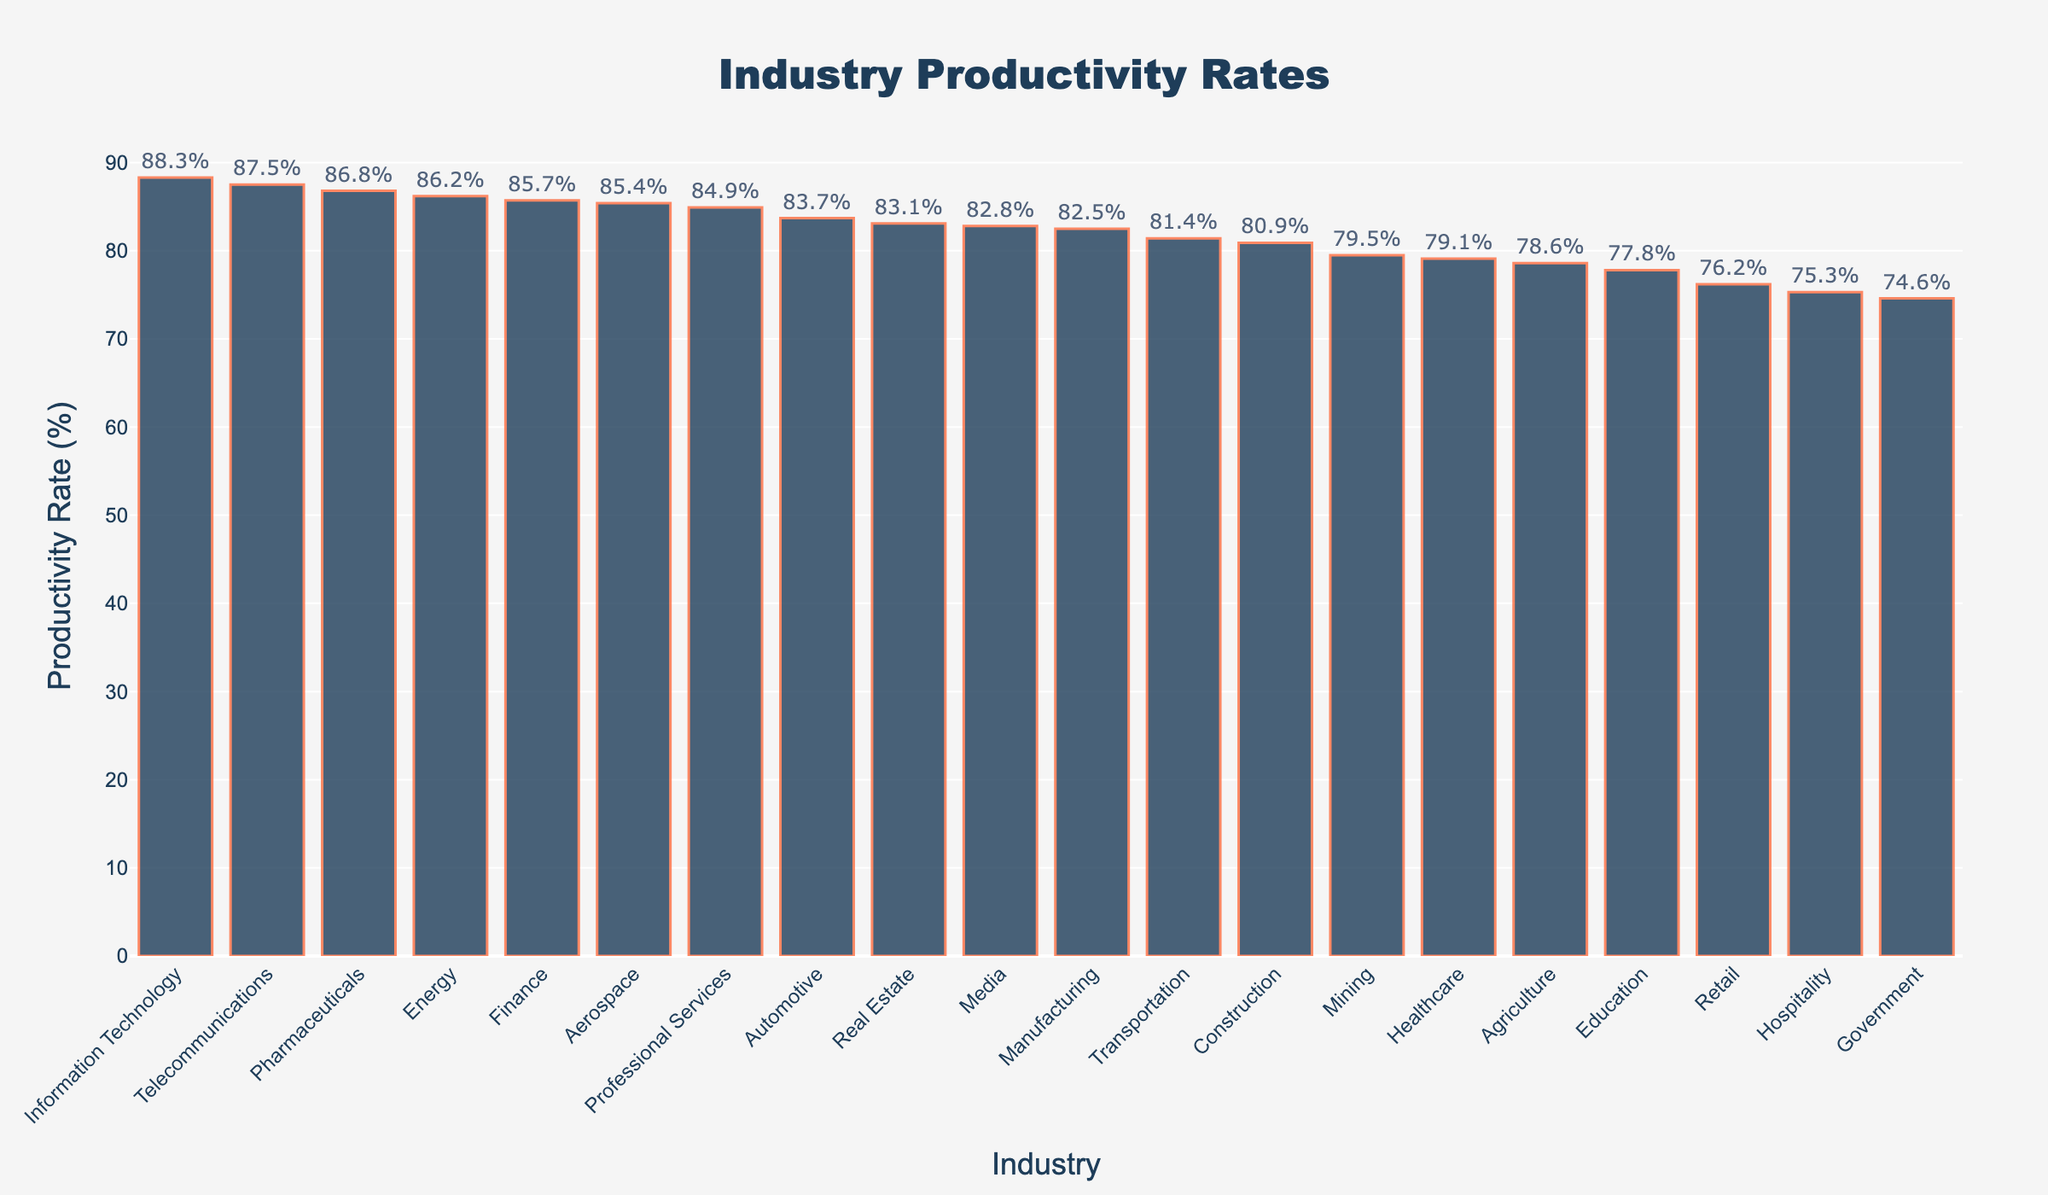Which industry has the highest productivity rate? The highest bar represents the industry with the highest productivity rate.
Answer: Information Technology Which industry has the lowest productivity rate? The lowest bar represents the industry with the lowest productivity rate.
Answer: Government What is the difference in productivity rates between Manufacturing and Retail? Look at and subtract the productivity rates of Manufacturing (82.5%) and Retail (76.2%). The difference is 82.5% - 76.2%.
Answer: 6.3% How many industries have a productivity rate above 85%? Count the bars with productivity rates above the 85% mark on the y-axis.
Answer: 6 Which industries have a productivity rate between 80% and 85% inclusive? Identify bars within the 80%-85% range on the y-axis.
Answer: Real Estate, Professional Services, Automotive, Transportation, Construction Is the productivity rate of Finance higher than that of Education? Compare the heights of the bars for Finance and Education or refer to their values.
Answer: Yes What is the average productivity rate of the top 5 industries? Sum the productivity rates of the top 5 industries (88.3%, 87.5%, 86.8%, 86.2%, 85.7%) and divide by 5.
Answer: 86.9% Which two industries have the closest productivity rates to each other? Find two bars whose heights are closest to each other or their values are closest.
Answer: Media and Manufacturing What is the productivity rate range (difference between the highest and lowest rates) across all industries? Subtract the lowest productivity rate (74.6%) from the highest (88.3%).
Answer: 13.7% How does the productivity rate of Pharmaceuticals compare to that of Mining? Compare the heights of the bars for Pharmaceuticals and Mining or refer to their values.
Answer: Pharmaceuticals is higher 